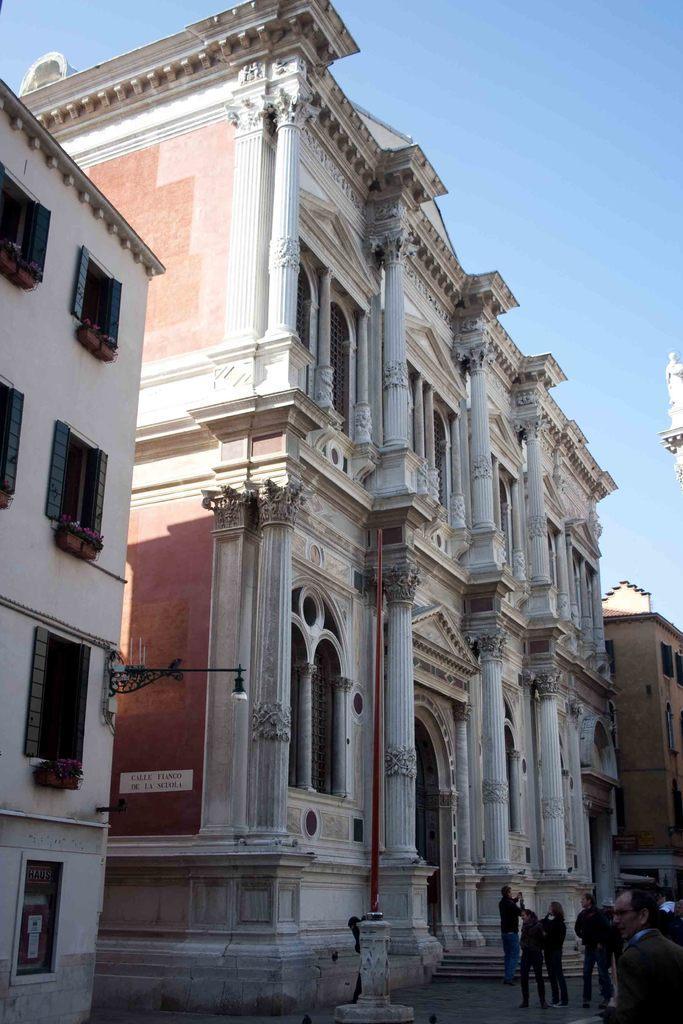How would you summarize this image in a sentence or two? In this image I can see group of people standing. In the background I can see few buildings and the sky is in blue and white color. 